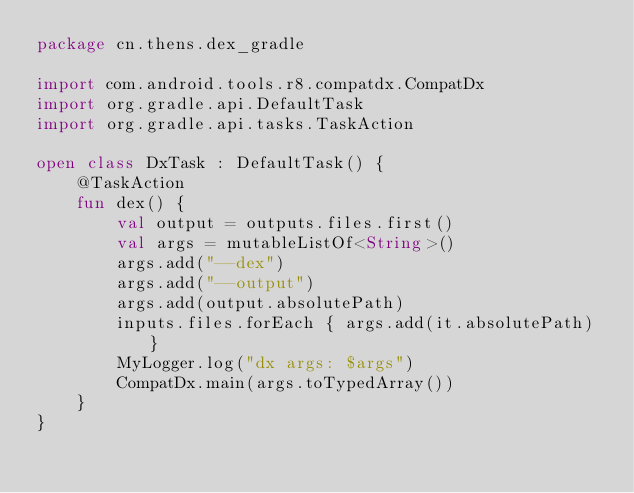<code> <loc_0><loc_0><loc_500><loc_500><_Kotlin_>package cn.thens.dex_gradle

import com.android.tools.r8.compatdx.CompatDx
import org.gradle.api.DefaultTask
import org.gradle.api.tasks.TaskAction

open class DxTask : DefaultTask() {
    @TaskAction
    fun dex() {
        val output = outputs.files.first()
        val args = mutableListOf<String>()
        args.add("--dex")
        args.add("--output")
        args.add(output.absolutePath)
        inputs.files.forEach { args.add(it.absolutePath) }
        MyLogger.log("dx args: $args")
        CompatDx.main(args.toTypedArray())
    }
}</code> 